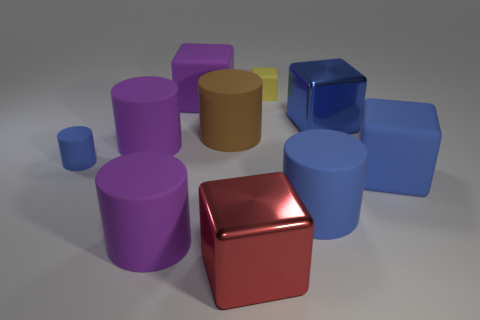What is the material of the other cylinder that is the same color as the small cylinder?
Offer a terse response. Rubber. What is the material of the other tiny object that is the same shape as the brown object?
Keep it short and to the point. Rubber. How many other things are the same shape as the large blue metallic thing?
Make the answer very short. 4. What is the size of the shiny block in front of the large metal block on the right side of the large matte cylinder on the right side of the yellow matte block?
Offer a very short reply. Large. How many blue things are either shiny things or tiny objects?
Your response must be concise. 2. The matte thing that is to the right of the matte cylinder that is to the right of the small yellow matte object is what shape?
Your answer should be very brief. Cube. Is the size of the metallic block that is on the right side of the red metallic cube the same as the blue cube that is in front of the tiny cylinder?
Your answer should be compact. Yes. Are there any big purple blocks that have the same material as the small blue cylinder?
Keep it short and to the point. Yes. There is another rubber cylinder that is the same color as the tiny cylinder; what is its size?
Keep it short and to the point. Large. There is a blue matte cylinder that is to the left of the matte cube behind the purple block; is there a big blue cylinder left of it?
Give a very brief answer. No. 